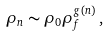<formula> <loc_0><loc_0><loc_500><loc_500>\rho _ { n } \sim \rho _ { 0 } \rho _ { f } ^ { g ( n ) } \, ,</formula> 